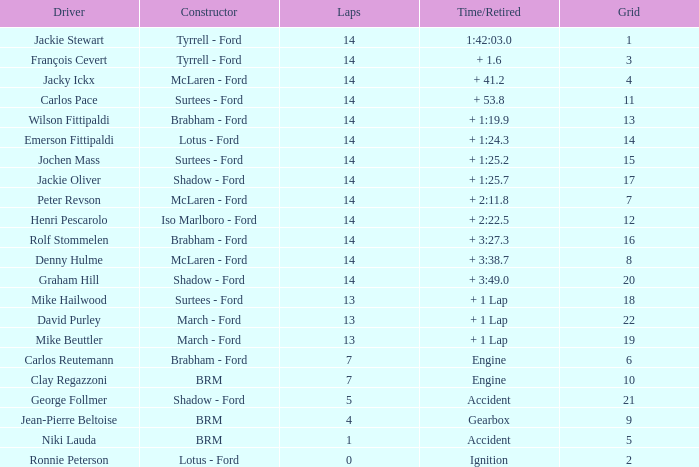3? 14.0. 